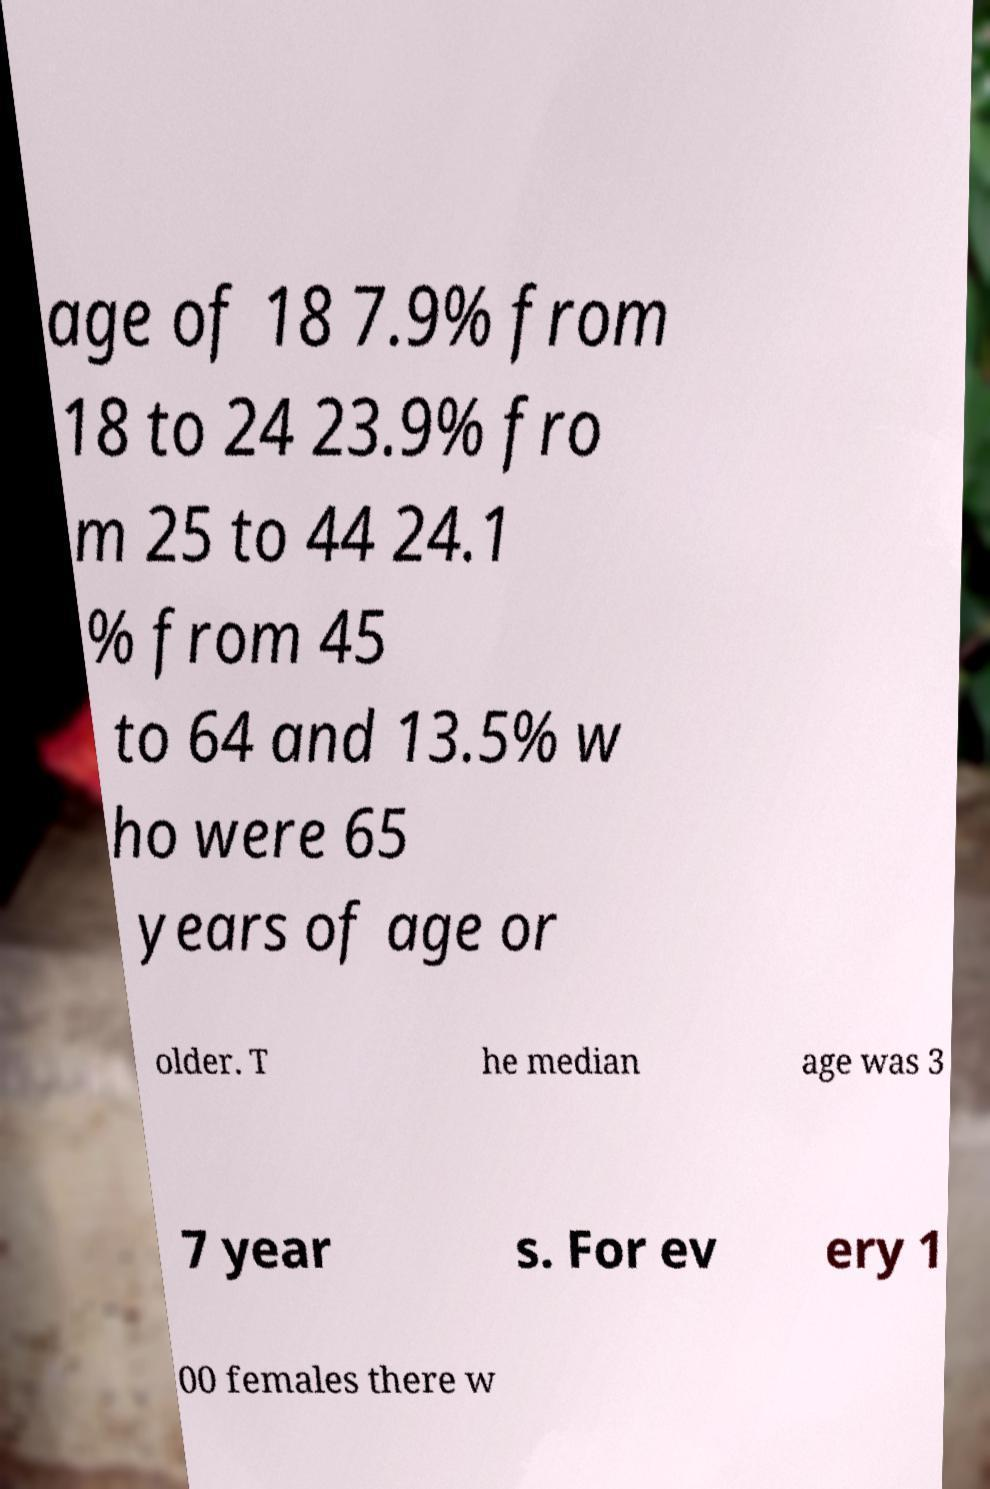For documentation purposes, I need the text within this image transcribed. Could you provide that? age of 18 7.9% from 18 to 24 23.9% fro m 25 to 44 24.1 % from 45 to 64 and 13.5% w ho were 65 years of age or older. T he median age was 3 7 year s. For ev ery 1 00 females there w 